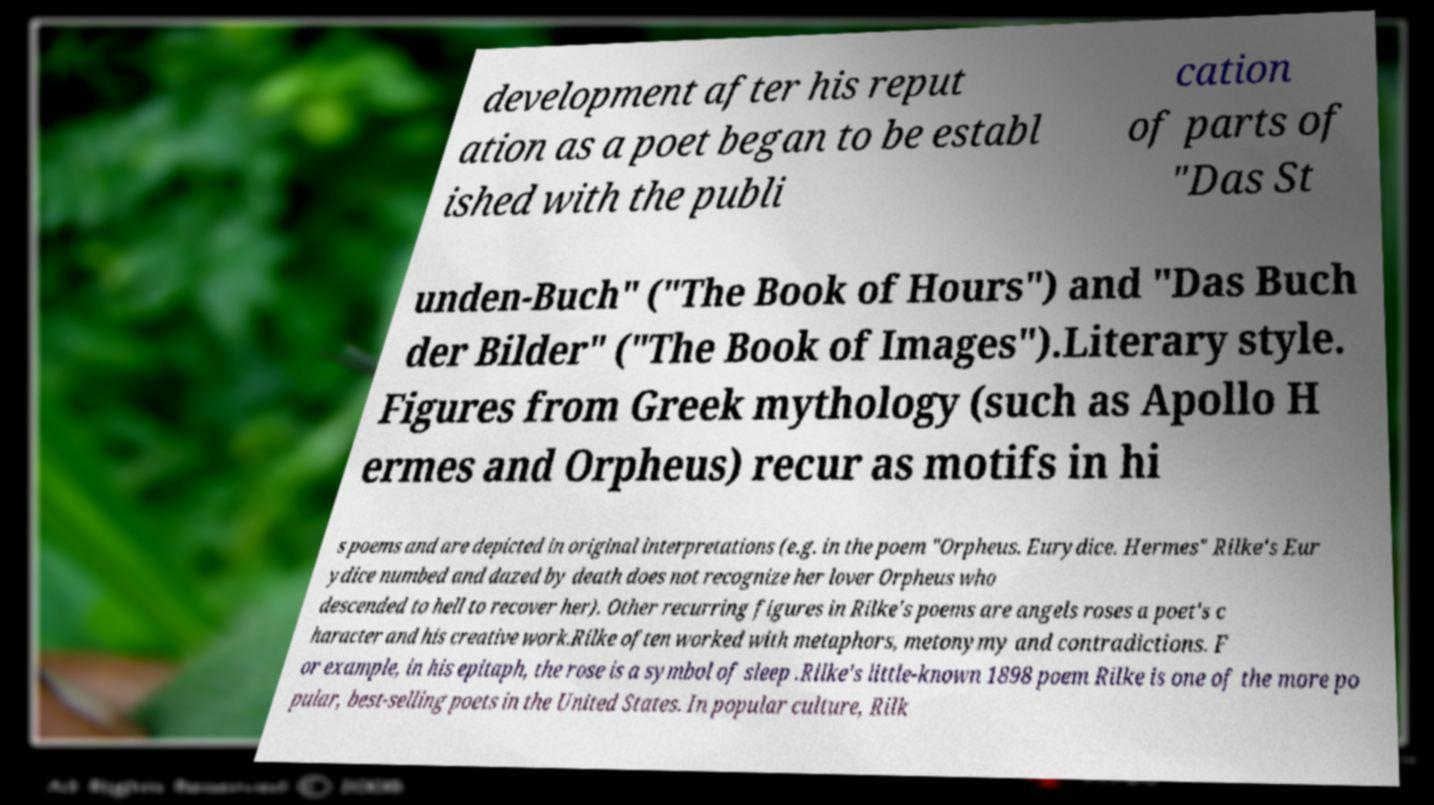For documentation purposes, I need the text within this image transcribed. Could you provide that? development after his reput ation as a poet began to be establ ished with the publi cation of parts of "Das St unden-Buch" ("The Book of Hours") and "Das Buch der Bilder" ("The Book of Images").Literary style. Figures from Greek mythology (such as Apollo H ermes and Orpheus) recur as motifs in hi s poems and are depicted in original interpretations (e.g. in the poem "Orpheus. Eurydice. Hermes" Rilke's Eur ydice numbed and dazed by death does not recognize her lover Orpheus who descended to hell to recover her). Other recurring figures in Rilke's poems are angels roses a poet's c haracter and his creative work.Rilke often worked with metaphors, metonymy and contradictions. F or example, in his epitaph, the rose is a symbol of sleep .Rilke's little-known 1898 poem Rilke is one of the more po pular, best-selling poets in the United States. In popular culture, Rilk 